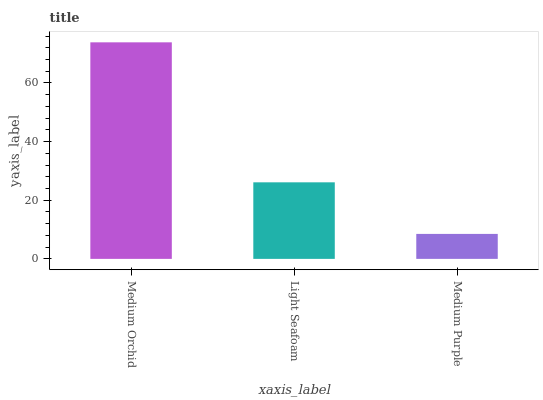Is Medium Purple the minimum?
Answer yes or no. Yes. Is Medium Orchid the maximum?
Answer yes or no. Yes. Is Light Seafoam the minimum?
Answer yes or no. No. Is Light Seafoam the maximum?
Answer yes or no. No. Is Medium Orchid greater than Light Seafoam?
Answer yes or no. Yes. Is Light Seafoam less than Medium Orchid?
Answer yes or no. Yes. Is Light Seafoam greater than Medium Orchid?
Answer yes or no. No. Is Medium Orchid less than Light Seafoam?
Answer yes or no. No. Is Light Seafoam the high median?
Answer yes or no. Yes. Is Light Seafoam the low median?
Answer yes or no. Yes. Is Medium Orchid the high median?
Answer yes or no. No. Is Medium Purple the low median?
Answer yes or no. No. 